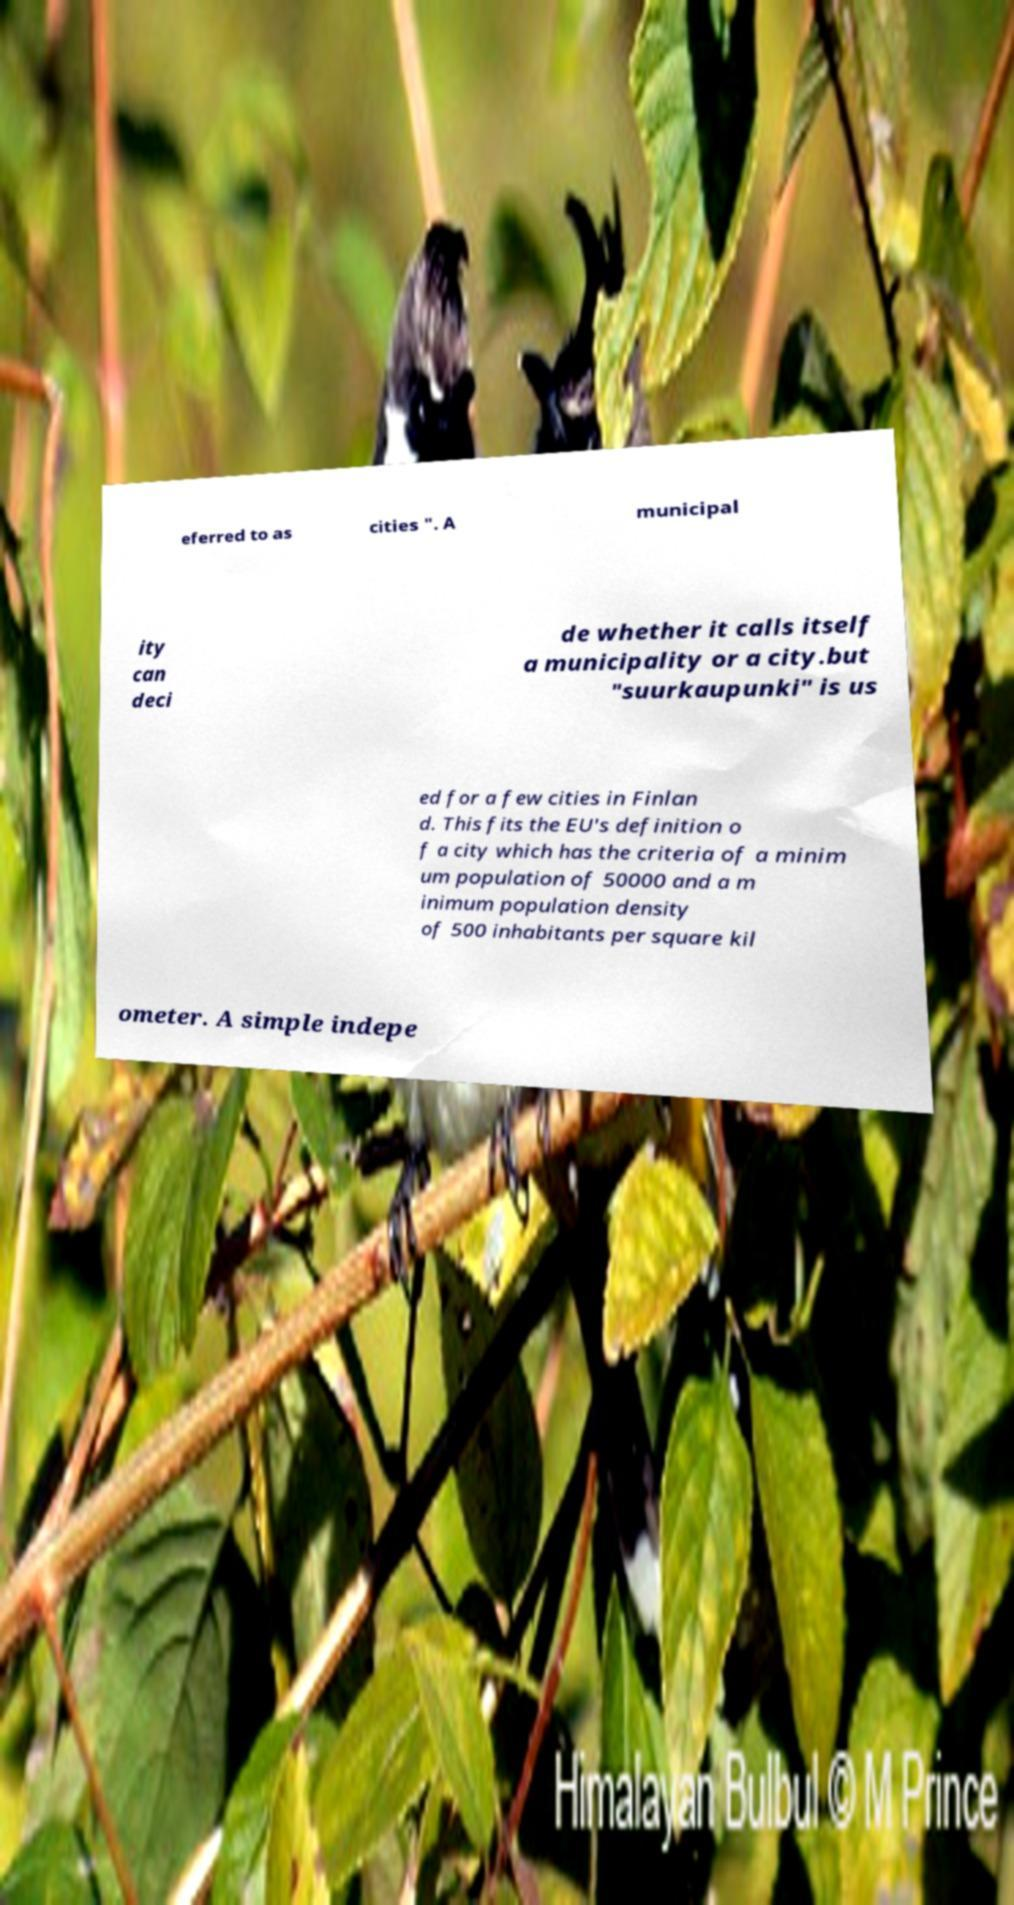There's text embedded in this image that I need extracted. Can you transcribe it verbatim? eferred to as cities ". A municipal ity can deci de whether it calls itself a municipality or a city.but "suurkaupunki" is us ed for a few cities in Finlan d. This fits the EU's definition o f a city which has the criteria of a minim um population of 50000 and a m inimum population density of 500 inhabitants per square kil ometer. A simple indepe 